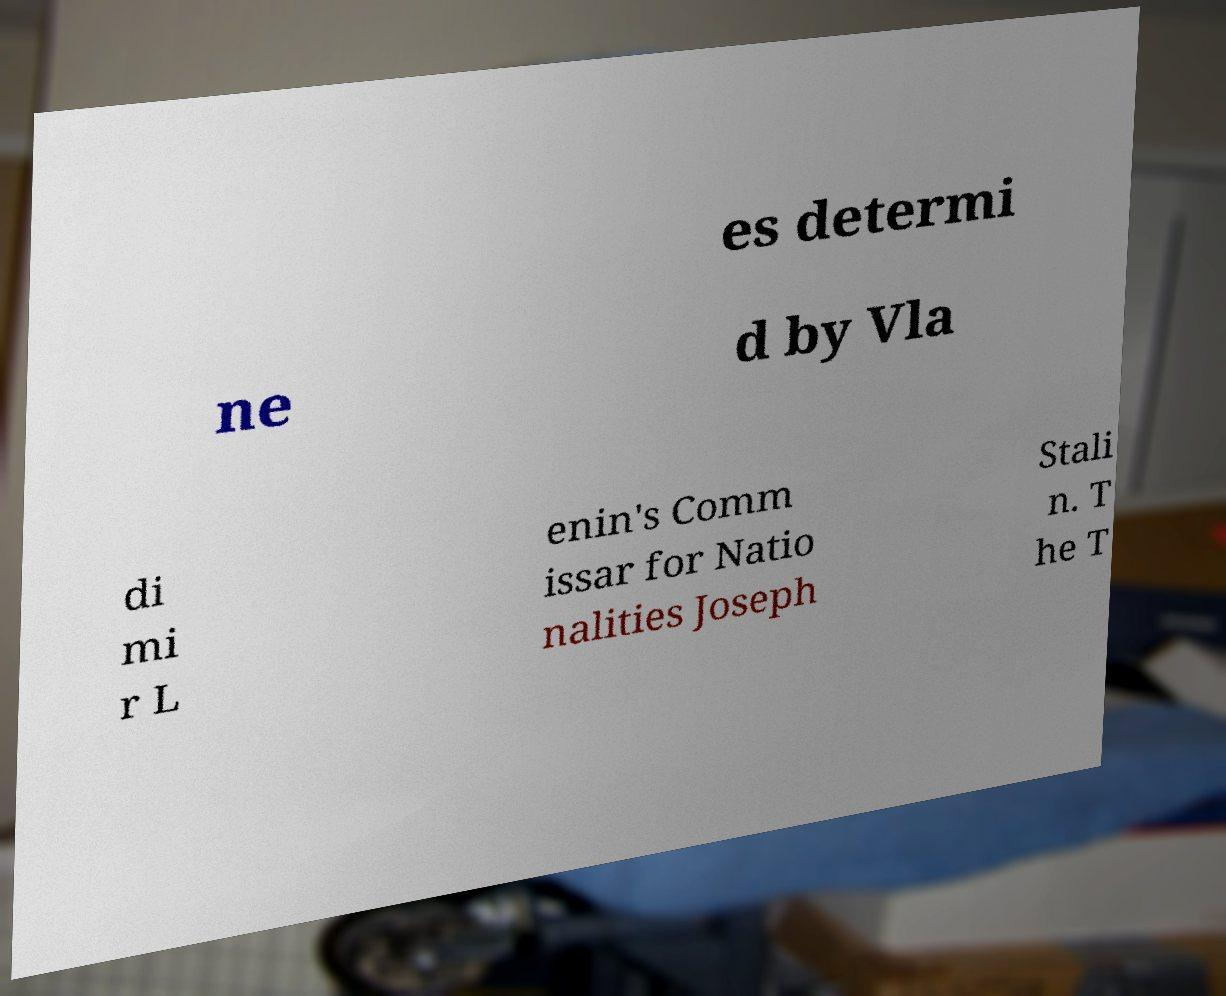I need the written content from this picture converted into text. Can you do that? es determi ne d by Vla di mi r L enin's Comm issar for Natio nalities Joseph Stali n. T he T 